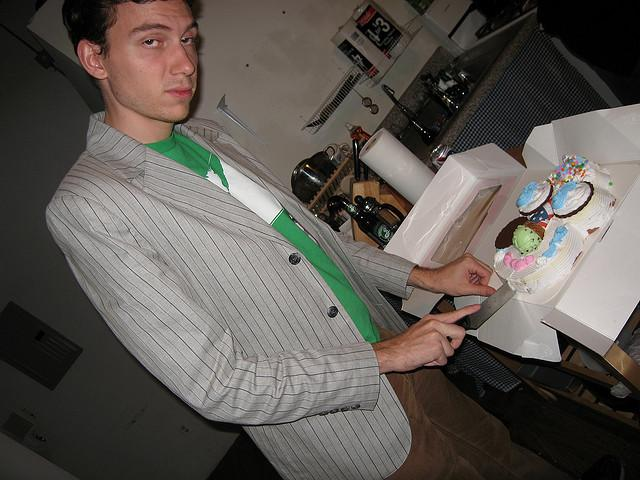What is inside the cake being cut?

Choices:
A) marshmallows
B) bread
C) ice cream
D) angel food ice cream 